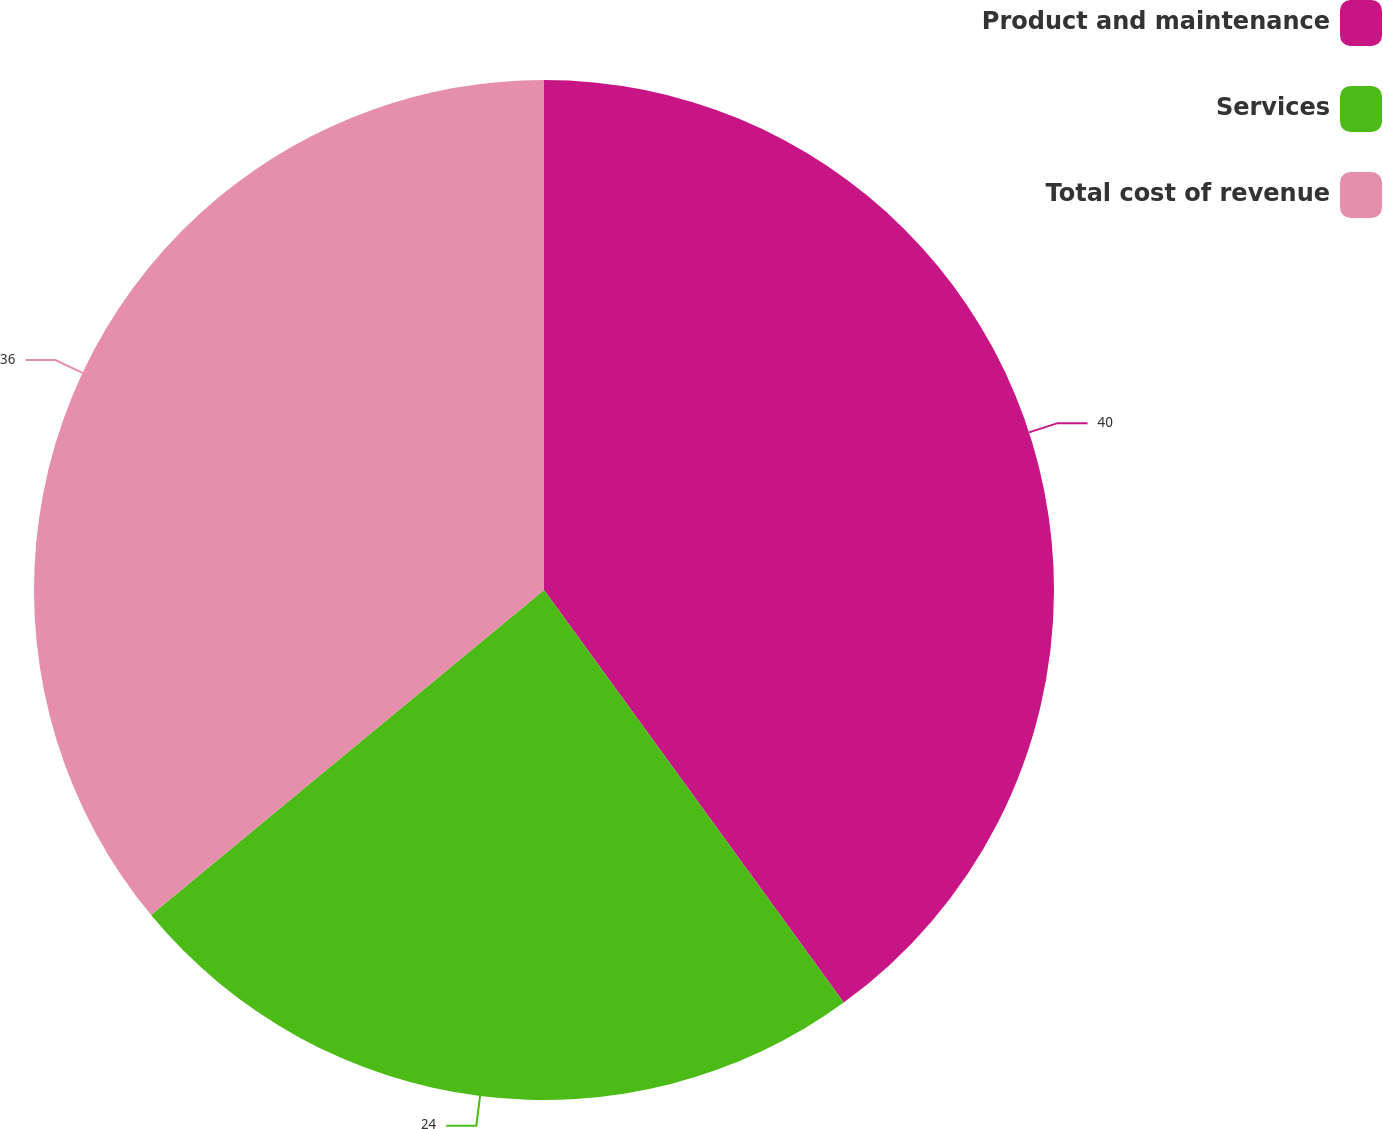Convert chart to OTSL. <chart><loc_0><loc_0><loc_500><loc_500><pie_chart><fcel>Product and maintenance<fcel>Services<fcel>Total cost of revenue<nl><fcel>40.0%<fcel>24.0%<fcel>36.0%<nl></chart> 